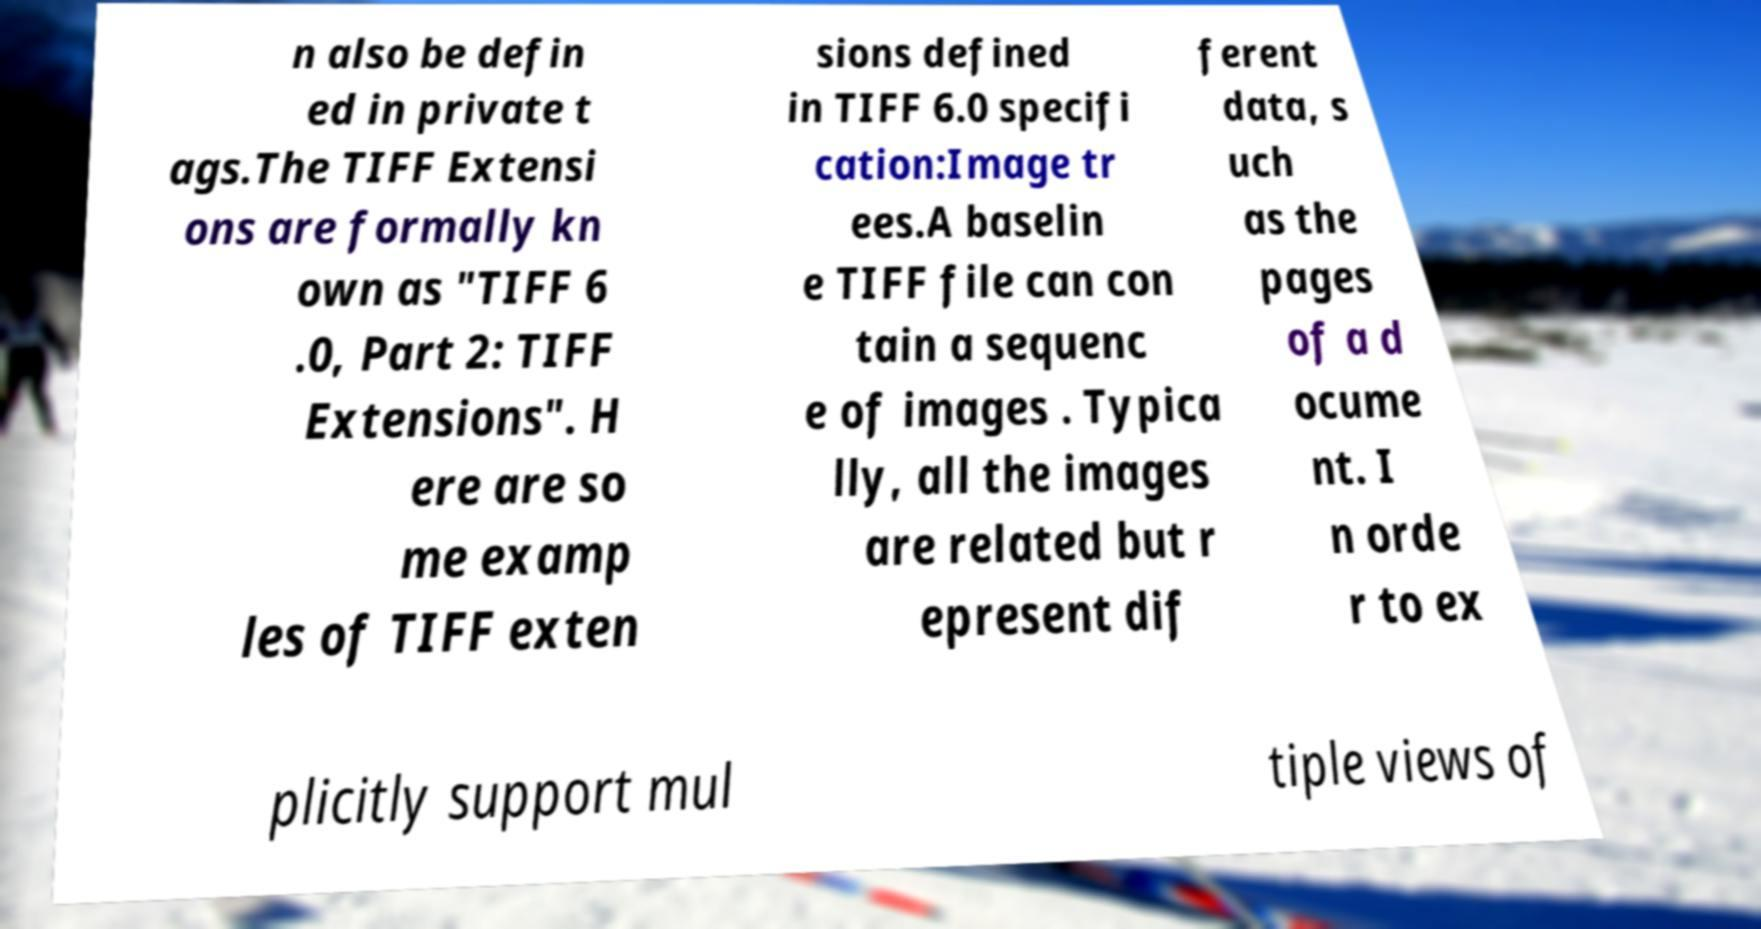Could you extract and type out the text from this image? n also be defin ed in private t ags.The TIFF Extensi ons are formally kn own as "TIFF 6 .0, Part 2: TIFF Extensions". H ere are so me examp les of TIFF exten sions defined in TIFF 6.0 specifi cation:Image tr ees.A baselin e TIFF file can con tain a sequenc e of images . Typica lly, all the images are related but r epresent dif ferent data, s uch as the pages of a d ocume nt. I n orde r to ex plicitly support mul tiple views of 